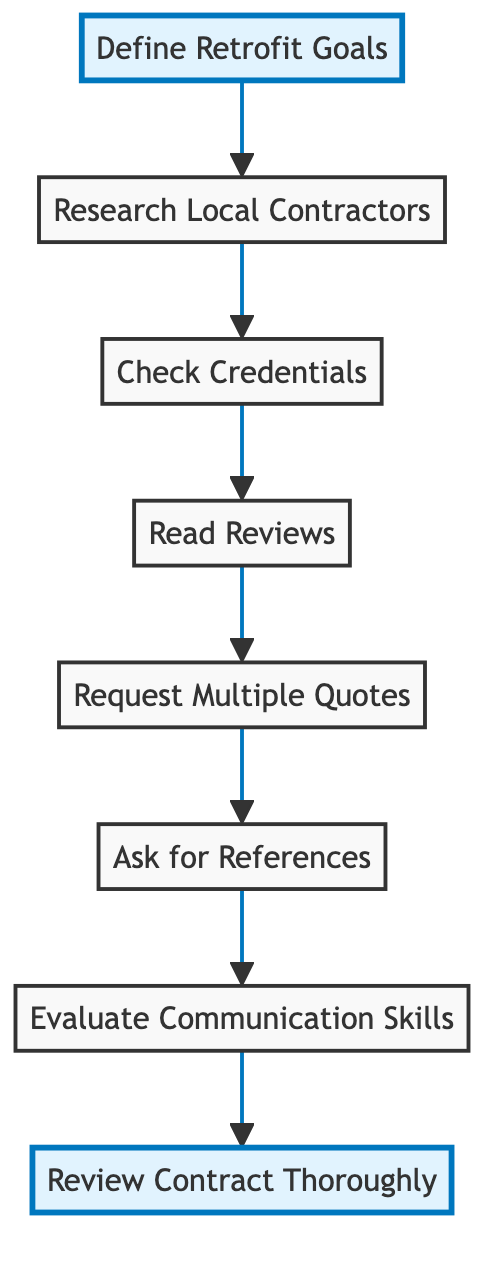What is the first step in the flowchart? The first node in the flowchart is labeled "Define Retrofit Goals," which indicates that this is the starting point.
Answer: Define Retrofit Goals How many main steps are shown in the flowchart? The diagram contains eight distinct nodes that represent individual steps in the process of selecting a qualified contractor for a seismic retrofit.
Answer: Eight What should you do after researching local contractors? After researching local contractors, the next step indicated by the flowchart is to check their credentials for proper licensing and insurance.
Answer: Check Credentials What is the last step in the process according to the flowchart? The final node in the flowchart is "Review Contract Thoroughly," which represents the concluding step in selecting a contractor.
Answer: Review Contract Thoroughly What relationship exists between "Request Multiple Quotes" and "Ask for References"? "Request Multiple Quotes" is followed by "Ask for References," indicating that after obtaining quotes, you should contact previous clients for their feedback.
Answer: Sequential How many steps involve checking and assessing contractor qualifications? The steps "Check Credentials," "Read Reviews," and "Ask for References" all involve checking and assessing various qualifications or experiences of the contractors. Thus, there are three such steps.
Answer: Three Which step emphasizes evaluating communication? The node labeled "Evaluate Communication Skills" specifically highlights the importance of assessing how well the contractor communicates and responds.
Answer: Evaluate Communication Skills What type of chart is portrayed here? This diagram represents a flowchart, which is used to outline steps in a process or a decision-making pathway.
Answer: Flowchart 